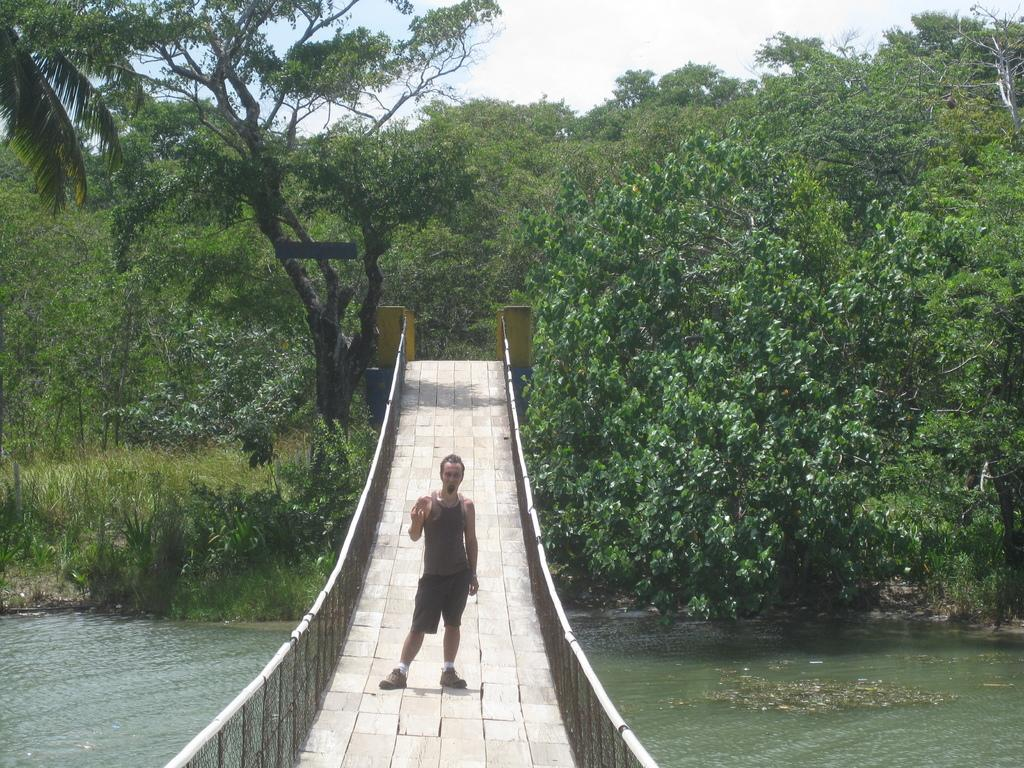What is the man in the image doing? The man is standing on a bridge in the image. What can be seen below the bridge? There is: There is water visible at the bottom of the image. What type of environment is visible in the background of the image? There are many trees in the background of the image, suggesting it is near a forest. Can you describe the setting of the image? The image appears to be taken near a forest, with a bridge crossing over a body of water. What type of drawer can be seen in the man's hand in the image? There is no drawer present in the image; the man is standing on a bridge with no visible objects in his hand. 